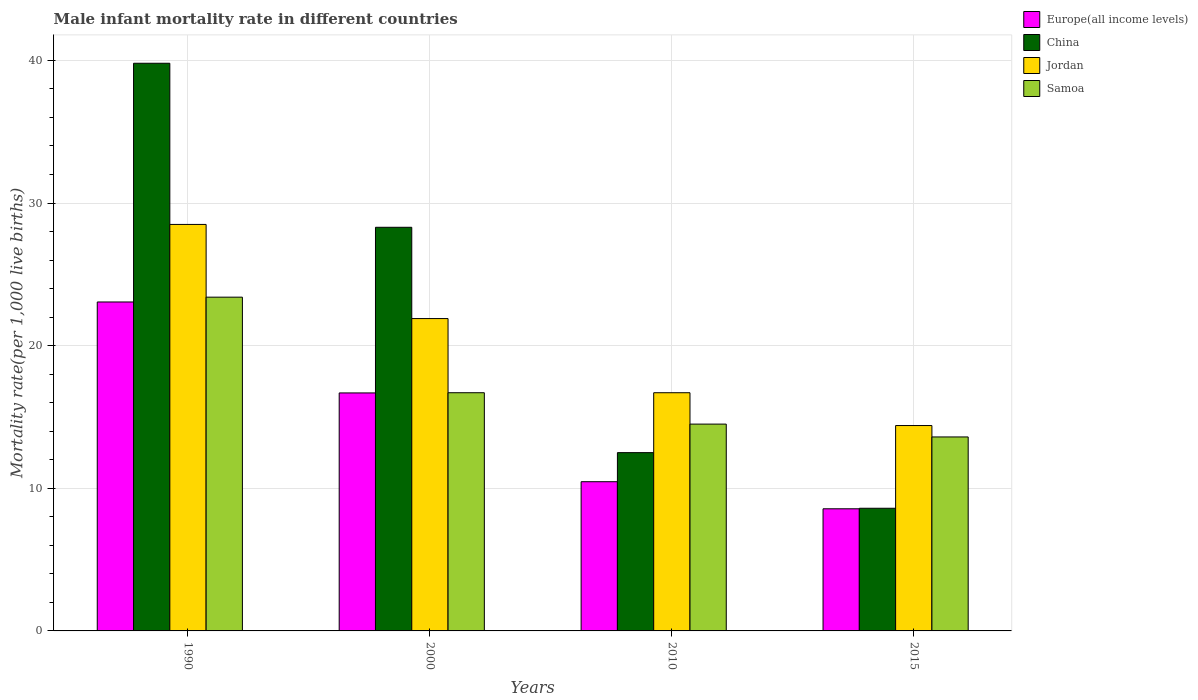How many different coloured bars are there?
Your response must be concise. 4. How many groups of bars are there?
Give a very brief answer. 4. Are the number of bars on each tick of the X-axis equal?
Make the answer very short. Yes. How many bars are there on the 1st tick from the left?
Keep it short and to the point. 4. How many bars are there on the 2nd tick from the right?
Make the answer very short. 4. What is the label of the 3rd group of bars from the left?
Provide a short and direct response. 2010. What is the male infant mortality rate in China in 1990?
Keep it short and to the point. 39.8. Across all years, what is the maximum male infant mortality rate in China?
Give a very brief answer. 39.8. Across all years, what is the minimum male infant mortality rate in China?
Offer a very short reply. 8.6. In which year was the male infant mortality rate in Europe(all income levels) minimum?
Provide a short and direct response. 2015. What is the total male infant mortality rate in China in the graph?
Your answer should be very brief. 89.2. What is the difference between the male infant mortality rate in Europe(all income levels) in 1990 and that in 2010?
Provide a succinct answer. 12.6. What is the difference between the male infant mortality rate in China in 2015 and the male infant mortality rate in Jordan in 1990?
Your answer should be compact. -19.9. What is the average male infant mortality rate in Europe(all income levels) per year?
Give a very brief answer. 14.69. In the year 2000, what is the difference between the male infant mortality rate in Europe(all income levels) and male infant mortality rate in Samoa?
Offer a terse response. -0.01. What is the ratio of the male infant mortality rate in Europe(all income levels) in 1990 to that in 2010?
Offer a very short reply. 2.2. Is the male infant mortality rate in Samoa in 2010 less than that in 2015?
Keep it short and to the point. No. What is the difference between the highest and the second highest male infant mortality rate in China?
Your answer should be very brief. 11.5. What is the difference between the highest and the lowest male infant mortality rate in Samoa?
Your answer should be compact. 9.8. In how many years, is the male infant mortality rate in Europe(all income levels) greater than the average male infant mortality rate in Europe(all income levels) taken over all years?
Provide a short and direct response. 2. What does the 4th bar from the right in 2000 represents?
Make the answer very short. Europe(all income levels). How many bars are there?
Offer a very short reply. 16. How many years are there in the graph?
Your answer should be very brief. 4. Does the graph contain grids?
Your answer should be very brief. Yes. How are the legend labels stacked?
Offer a very short reply. Vertical. What is the title of the graph?
Make the answer very short. Male infant mortality rate in different countries. Does "Thailand" appear as one of the legend labels in the graph?
Keep it short and to the point. No. What is the label or title of the Y-axis?
Your answer should be very brief. Mortality rate(per 1,0 live births). What is the Mortality rate(per 1,000 live births) in Europe(all income levels) in 1990?
Give a very brief answer. 23.06. What is the Mortality rate(per 1,000 live births) of China in 1990?
Your answer should be compact. 39.8. What is the Mortality rate(per 1,000 live births) of Samoa in 1990?
Keep it short and to the point. 23.4. What is the Mortality rate(per 1,000 live births) of Europe(all income levels) in 2000?
Ensure brevity in your answer.  16.69. What is the Mortality rate(per 1,000 live births) of China in 2000?
Ensure brevity in your answer.  28.3. What is the Mortality rate(per 1,000 live births) of Jordan in 2000?
Offer a terse response. 21.9. What is the Mortality rate(per 1,000 live births) of Europe(all income levels) in 2010?
Offer a terse response. 10.46. What is the Mortality rate(per 1,000 live births) of China in 2010?
Your answer should be very brief. 12.5. What is the Mortality rate(per 1,000 live births) in Jordan in 2010?
Offer a terse response. 16.7. What is the Mortality rate(per 1,000 live births) in Europe(all income levels) in 2015?
Your answer should be very brief. 8.56. Across all years, what is the maximum Mortality rate(per 1,000 live births) of Europe(all income levels)?
Offer a very short reply. 23.06. Across all years, what is the maximum Mortality rate(per 1,000 live births) of China?
Make the answer very short. 39.8. Across all years, what is the maximum Mortality rate(per 1,000 live births) of Jordan?
Give a very brief answer. 28.5. Across all years, what is the maximum Mortality rate(per 1,000 live births) of Samoa?
Provide a short and direct response. 23.4. Across all years, what is the minimum Mortality rate(per 1,000 live births) of Europe(all income levels)?
Your answer should be compact. 8.56. Across all years, what is the minimum Mortality rate(per 1,000 live births) of China?
Make the answer very short. 8.6. What is the total Mortality rate(per 1,000 live births) of Europe(all income levels) in the graph?
Your response must be concise. 58.77. What is the total Mortality rate(per 1,000 live births) of China in the graph?
Ensure brevity in your answer.  89.2. What is the total Mortality rate(per 1,000 live births) in Jordan in the graph?
Give a very brief answer. 81.5. What is the total Mortality rate(per 1,000 live births) in Samoa in the graph?
Ensure brevity in your answer.  68.2. What is the difference between the Mortality rate(per 1,000 live births) in Europe(all income levels) in 1990 and that in 2000?
Your answer should be very brief. 6.38. What is the difference between the Mortality rate(per 1,000 live births) in China in 1990 and that in 2000?
Provide a short and direct response. 11.5. What is the difference between the Mortality rate(per 1,000 live births) of Europe(all income levels) in 1990 and that in 2010?
Your answer should be very brief. 12.6. What is the difference between the Mortality rate(per 1,000 live births) of China in 1990 and that in 2010?
Ensure brevity in your answer.  27.3. What is the difference between the Mortality rate(per 1,000 live births) in Europe(all income levels) in 1990 and that in 2015?
Make the answer very short. 14.5. What is the difference between the Mortality rate(per 1,000 live births) of China in 1990 and that in 2015?
Give a very brief answer. 31.2. What is the difference between the Mortality rate(per 1,000 live births) of Europe(all income levels) in 2000 and that in 2010?
Your response must be concise. 6.22. What is the difference between the Mortality rate(per 1,000 live births) in China in 2000 and that in 2010?
Give a very brief answer. 15.8. What is the difference between the Mortality rate(per 1,000 live births) in Samoa in 2000 and that in 2010?
Your response must be concise. 2.2. What is the difference between the Mortality rate(per 1,000 live births) of Europe(all income levels) in 2000 and that in 2015?
Your response must be concise. 8.12. What is the difference between the Mortality rate(per 1,000 live births) in China in 2000 and that in 2015?
Your answer should be compact. 19.7. What is the difference between the Mortality rate(per 1,000 live births) in Samoa in 2000 and that in 2015?
Provide a short and direct response. 3.1. What is the difference between the Mortality rate(per 1,000 live births) of Europe(all income levels) in 2010 and that in 2015?
Give a very brief answer. 1.9. What is the difference between the Mortality rate(per 1,000 live births) in China in 2010 and that in 2015?
Ensure brevity in your answer.  3.9. What is the difference between the Mortality rate(per 1,000 live births) in Europe(all income levels) in 1990 and the Mortality rate(per 1,000 live births) in China in 2000?
Offer a very short reply. -5.24. What is the difference between the Mortality rate(per 1,000 live births) of Europe(all income levels) in 1990 and the Mortality rate(per 1,000 live births) of Jordan in 2000?
Give a very brief answer. 1.16. What is the difference between the Mortality rate(per 1,000 live births) in Europe(all income levels) in 1990 and the Mortality rate(per 1,000 live births) in Samoa in 2000?
Your answer should be very brief. 6.36. What is the difference between the Mortality rate(per 1,000 live births) of China in 1990 and the Mortality rate(per 1,000 live births) of Jordan in 2000?
Provide a succinct answer. 17.9. What is the difference between the Mortality rate(per 1,000 live births) in China in 1990 and the Mortality rate(per 1,000 live births) in Samoa in 2000?
Your answer should be very brief. 23.1. What is the difference between the Mortality rate(per 1,000 live births) in Jordan in 1990 and the Mortality rate(per 1,000 live births) in Samoa in 2000?
Offer a very short reply. 11.8. What is the difference between the Mortality rate(per 1,000 live births) of Europe(all income levels) in 1990 and the Mortality rate(per 1,000 live births) of China in 2010?
Your answer should be very brief. 10.56. What is the difference between the Mortality rate(per 1,000 live births) in Europe(all income levels) in 1990 and the Mortality rate(per 1,000 live births) in Jordan in 2010?
Your answer should be very brief. 6.36. What is the difference between the Mortality rate(per 1,000 live births) in Europe(all income levels) in 1990 and the Mortality rate(per 1,000 live births) in Samoa in 2010?
Offer a very short reply. 8.56. What is the difference between the Mortality rate(per 1,000 live births) in China in 1990 and the Mortality rate(per 1,000 live births) in Jordan in 2010?
Offer a very short reply. 23.1. What is the difference between the Mortality rate(per 1,000 live births) of China in 1990 and the Mortality rate(per 1,000 live births) of Samoa in 2010?
Provide a succinct answer. 25.3. What is the difference between the Mortality rate(per 1,000 live births) in Jordan in 1990 and the Mortality rate(per 1,000 live births) in Samoa in 2010?
Your answer should be compact. 14. What is the difference between the Mortality rate(per 1,000 live births) of Europe(all income levels) in 1990 and the Mortality rate(per 1,000 live births) of China in 2015?
Ensure brevity in your answer.  14.46. What is the difference between the Mortality rate(per 1,000 live births) in Europe(all income levels) in 1990 and the Mortality rate(per 1,000 live births) in Jordan in 2015?
Keep it short and to the point. 8.66. What is the difference between the Mortality rate(per 1,000 live births) in Europe(all income levels) in 1990 and the Mortality rate(per 1,000 live births) in Samoa in 2015?
Ensure brevity in your answer.  9.46. What is the difference between the Mortality rate(per 1,000 live births) in China in 1990 and the Mortality rate(per 1,000 live births) in Jordan in 2015?
Provide a short and direct response. 25.4. What is the difference between the Mortality rate(per 1,000 live births) of China in 1990 and the Mortality rate(per 1,000 live births) of Samoa in 2015?
Provide a short and direct response. 26.2. What is the difference between the Mortality rate(per 1,000 live births) of Jordan in 1990 and the Mortality rate(per 1,000 live births) of Samoa in 2015?
Your answer should be compact. 14.9. What is the difference between the Mortality rate(per 1,000 live births) in Europe(all income levels) in 2000 and the Mortality rate(per 1,000 live births) in China in 2010?
Ensure brevity in your answer.  4.19. What is the difference between the Mortality rate(per 1,000 live births) of Europe(all income levels) in 2000 and the Mortality rate(per 1,000 live births) of Jordan in 2010?
Your response must be concise. -0.01. What is the difference between the Mortality rate(per 1,000 live births) of Europe(all income levels) in 2000 and the Mortality rate(per 1,000 live births) of Samoa in 2010?
Ensure brevity in your answer.  2.19. What is the difference between the Mortality rate(per 1,000 live births) of Jordan in 2000 and the Mortality rate(per 1,000 live births) of Samoa in 2010?
Give a very brief answer. 7.4. What is the difference between the Mortality rate(per 1,000 live births) in Europe(all income levels) in 2000 and the Mortality rate(per 1,000 live births) in China in 2015?
Ensure brevity in your answer.  8.09. What is the difference between the Mortality rate(per 1,000 live births) in Europe(all income levels) in 2000 and the Mortality rate(per 1,000 live births) in Jordan in 2015?
Provide a succinct answer. 2.29. What is the difference between the Mortality rate(per 1,000 live births) in Europe(all income levels) in 2000 and the Mortality rate(per 1,000 live births) in Samoa in 2015?
Make the answer very short. 3.09. What is the difference between the Mortality rate(per 1,000 live births) of Jordan in 2000 and the Mortality rate(per 1,000 live births) of Samoa in 2015?
Your answer should be very brief. 8.3. What is the difference between the Mortality rate(per 1,000 live births) in Europe(all income levels) in 2010 and the Mortality rate(per 1,000 live births) in China in 2015?
Give a very brief answer. 1.86. What is the difference between the Mortality rate(per 1,000 live births) in Europe(all income levels) in 2010 and the Mortality rate(per 1,000 live births) in Jordan in 2015?
Your response must be concise. -3.94. What is the difference between the Mortality rate(per 1,000 live births) in Europe(all income levels) in 2010 and the Mortality rate(per 1,000 live births) in Samoa in 2015?
Provide a succinct answer. -3.14. What is the difference between the Mortality rate(per 1,000 live births) in China in 2010 and the Mortality rate(per 1,000 live births) in Jordan in 2015?
Ensure brevity in your answer.  -1.9. What is the difference between the Mortality rate(per 1,000 live births) of China in 2010 and the Mortality rate(per 1,000 live births) of Samoa in 2015?
Keep it short and to the point. -1.1. What is the difference between the Mortality rate(per 1,000 live births) in Jordan in 2010 and the Mortality rate(per 1,000 live births) in Samoa in 2015?
Make the answer very short. 3.1. What is the average Mortality rate(per 1,000 live births) in Europe(all income levels) per year?
Your answer should be compact. 14.69. What is the average Mortality rate(per 1,000 live births) of China per year?
Your response must be concise. 22.3. What is the average Mortality rate(per 1,000 live births) of Jordan per year?
Your answer should be very brief. 20.38. What is the average Mortality rate(per 1,000 live births) in Samoa per year?
Offer a very short reply. 17.05. In the year 1990, what is the difference between the Mortality rate(per 1,000 live births) in Europe(all income levels) and Mortality rate(per 1,000 live births) in China?
Keep it short and to the point. -16.74. In the year 1990, what is the difference between the Mortality rate(per 1,000 live births) of Europe(all income levels) and Mortality rate(per 1,000 live births) of Jordan?
Provide a short and direct response. -5.44. In the year 1990, what is the difference between the Mortality rate(per 1,000 live births) in Europe(all income levels) and Mortality rate(per 1,000 live births) in Samoa?
Your response must be concise. -0.34. In the year 1990, what is the difference between the Mortality rate(per 1,000 live births) in China and Mortality rate(per 1,000 live births) in Jordan?
Your answer should be compact. 11.3. In the year 1990, what is the difference between the Mortality rate(per 1,000 live births) of Jordan and Mortality rate(per 1,000 live births) of Samoa?
Offer a terse response. 5.1. In the year 2000, what is the difference between the Mortality rate(per 1,000 live births) in Europe(all income levels) and Mortality rate(per 1,000 live births) in China?
Your answer should be compact. -11.61. In the year 2000, what is the difference between the Mortality rate(per 1,000 live births) in Europe(all income levels) and Mortality rate(per 1,000 live births) in Jordan?
Keep it short and to the point. -5.21. In the year 2000, what is the difference between the Mortality rate(per 1,000 live births) of Europe(all income levels) and Mortality rate(per 1,000 live births) of Samoa?
Make the answer very short. -0.01. In the year 2000, what is the difference between the Mortality rate(per 1,000 live births) in China and Mortality rate(per 1,000 live births) in Samoa?
Make the answer very short. 11.6. In the year 2000, what is the difference between the Mortality rate(per 1,000 live births) in Jordan and Mortality rate(per 1,000 live births) in Samoa?
Offer a terse response. 5.2. In the year 2010, what is the difference between the Mortality rate(per 1,000 live births) in Europe(all income levels) and Mortality rate(per 1,000 live births) in China?
Your answer should be very brief. -2.04. In the year 2010, what is the difference between the Mortality rate(per 1,000 live births) of Europe(all income levels) and Mortality rate(per 1,000 live births) of Jordan?
Ensure brevity in your answer.  -6.24. In the year 2010, what is the difference between the Mortality rate(per 1,000 live births) in Europe(all income levels) and Mortality rate(per 1,000 live births) in Samoa?
Your answer should be compact. -4.04. In the year 2010, what is the difference between the Mortality rate(per 1,000 live births) in Jordan and Mortality rate(per 1,000 live births) in Samoa?
Your answer should be very brief. 2.2. In the year 2015, what is the difference between the Mortality rate(per 1,000 live births) in Europe(all income levels) and Mortality rate(per 1,000 live births) in China?
Your response must be concise. -0.04. In the year 2015, what is the difference between the Mortality rate(per 1,000 live births) in Europe(all income levels) and Mortality rate(per 1,000 live births) in Jordan?
Offer a very short reply. -5.84. In the year 2015, what is the difference between the Mortality rate(per 1,000 live births) in Europe(all income levels) and Mortality rate(per 1,000 live births) in Samoa?
Make the answer very short. -5.04. In the year 2015, what is the difference between the Mortality rate(per 1,000 live births) in China and Mortality rate(per 1,000 live births) in Jordan?
Ensure brevity in your answer.  -5.8. In the year 2015, what is the difference between the Mortality rate(per 1,000 live births) of Jordan and Mortality rate(per 1,000 live births) of Samoa?
Your answer should be very brief. 0.8. What is the ratio of the Mortality rate(per 1,000 live births) in Europe(all income levels) in 1990 to that in 2000?
Make the answer very short. 1.38. What is the ratio of the Mortality rate(per 1,000 live births) in China in 1990 to that in 2000?
Make the answer very short. 1.41. What is the ratio of the Mortality rate(per 1,000 live births) in Jordan in 1990 to that in 2000?
Your answer should be compact. 1.3. What is the ratio of the Mortality rate(per 1,000 live births) in Samoa in 1990 to that in 2000?
Your response must be concise. 1.4. What is the ratio of the Mortality rate(per 1,000 live births) in Europe(all income levels) in 1990 to that in 2010?
Provide a short and direct response. 2.2. What is the ratio of the Mortality rate(per 1,000 live births) of China in 1990 to that in 2010?
Your response must be concise. 3.18. What is the ratio of the Mortality rate(per 1,000 live births) of Jordan in 1990 to that in 2010?
Offer a terse response. 1.71. What is the ratio of the Mortality rate(per 1,000 live births) of Samoa in 1990 to that in 2010?
Provide a short and direct response. 1.61. What is the ratio of the Mortality rate(per 1,000 live births) in Europe(all income levels) in 1990 to that in 2015?
Ensure brevity in your answer.  2.69. What is the ratio of the Mortality rate(per 1,000 live births) in China in 1990 to that in 2015?
Your answer should be very brief. 4.63. What is the ratio of the Mortality rate(per 1,000 live births) of Jordan in 1990 to that in 2015?
Provide a short and direct response. 1.98. What is the ratio of the Mortality rate(per 1,000 live births) in Samoa in 1990 to that in 2015?
Your answer should be very brief. 1.72. What is the ratio of the Mortality rate(per 1,000 live births) of Europe(all income levels) in 2000 to that in 2010?
Offer a terse response. 1.59. What is the ratio of the Mortality rate(per 1,000 live births) of China in 2000 to that in 2010?
Your answer should be very brief. 2.26. What is the ratio of the Mortality rate(per 1,000 live births) of Jordan in 2000 to that in 2010?
Ensure brevity in your answer.  1.31. What is the ratio of the Mortality rate(per 1,000 live births) of Samoa in 2000 to that in 2010?
Give a very brief answer. 1.15. What is the ratio of the Mortality rate(per 1,000 live births) in Europe(all income levels) in 2000 to that in 2015?
Keep it short and to the point. 1.95. What is the ratio of the Mortality rate(per 1,000 live births) of China in 2000 to that in 2015?
Keep it short and to the point. 3.29. What is the ratio of the Mortality rate(per 1,000 live births) of Jordan in 2000 to that in 2015?
Provide a succinct answer. 1.52. What is the ratio of the Mortality rate(per 1,000 live births) in Samoa in 2000 to that in 2015?
Give a very brief answer. 1.23. What is the ratio of the Mortality rate(per 1,000 live births) of Europe(all income levels) in 2010 to that in 2015?
Provide a succinct answer. 1.22. What is the ratio of the Mortality rate(per 1,000 live births) in China in 2010 to that in 2015?
Give a very brief answer. 1.45. What is the ratio of the Mortality rate(per 1,000 live births) in Jordan in 2010 to that in 2015?
Offer a very short reply. 1.16. What is the ratio of the Mortality rate(per 1,000 live births) in Samoa in 2010 to that in 2015?
Keep it short and to the point. 1.07. What is the difference between the highest and the second highest Mortality rate(per 1,000 live births) of Europe(all income levels)?
Offer a terse response. 6.38. What is the difference between the highest and the second highest Mortality rate(per 1,000 live births) of Jordan?
Ensure brevity in your answer.  6.6. What is the difference between the highest and the lowest Mortality rate(per 1,000 live births) in Europe(all income levels)?
Give a very brief answer. 14.5. What is the difference between the highest and the lowest Mortality rate(per 1,000 live births) of China?
Your answer should be compact. 31.2. What is the difference between the highest and the lowest Mortality rate(per 1,000 live births) of Jordan?
Keep it short and to the point. 14.1. What is the difference between the highest and the lowest Mortality rate(per 1,000 live births) in Samoa?
Offer a very short reply. 9.8. 